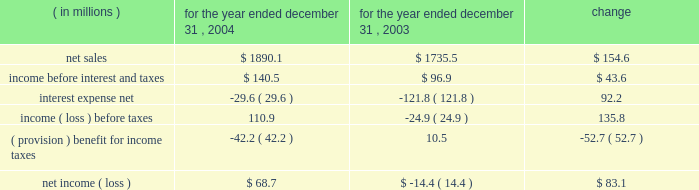Year ended december 31 , 2004 compared to year ended december 31 , 2003 the historical results of operations of pca for the years ended december 31 , 2004 and 2003 are set forth below : for the year ended december 31 , ( in millions ) 2004 2003 change .
Net sales net sales increased by $ 154.6 million , or 8.9% ( 8.9 % ) , for the year ended december 31 , 2004 from the year ended december 31 , 2003 .
Net sales increased due to improved sales volumes and prices of corrugated products and containerboard compared to 2003 .
Total corrugated products volume sold increased 6.6% ( 6.6 % ) to 29.9 billion square feet in 2004 compared to 28.1 billion square feet in 2003 .
On a comparable shipment-per-workday basis , corrugated products sales volume increased 7.0% ( 7.0 % ) in 2004 from 2003 .
Excluding pca 2019s acquisition of acorn in february 2004 , corrugated products volume was 5.3% ( 5.3 % ) higher in 2004 than 2003 and up 5.8% ( 5.8 % ) compared to 2003 on a shipment-per-workday basis .
Shipments-per-workday is calculated by dividing our total corrugated products volume during the year by the number of workdays within the year .
The larger percentage increase was due to the fact that 2004 had one less workday ( 251 days ) , those days not falling on a weekend or holiday , than 2003 ( 252 days ) .
Containerboard sales volume to external domestic and export customers increased 6.8% ( 6.8 % ) to 475000 tons for the year ended december 31 , 2004 from 445000 tons in 2003 .
Income before interest and taxes income before interest and taxes increased by $ 43.6 million , or 45.1% ( 45.1 % ) , for the year ended december 31 , 2004 compared to 2003 .
Included in income before interest and taxes for the year ended december 31 , 2004 is income of $ 27.8 million , net of expenses , attributable to a dividend paid to pca by stv , the timberlands joint venture in which pca owns a 311 20443% ( 20443 % ) ownership interest .
Included in income before interest and taxes for the year ended december 31 , 2003 is a $ 3.3 million charge for fees and expenses related to the company 2019s debt refinancing which was completed in july 2003 , and a fourth quarter charge of $ 16.0 million to settle certain benefits related matters with pactiv corporation dating back to april 12 , 1999 when pca became a stand-alone company , as described below .
During the fourth quarter of 2003 , pactiv notified pca that we owed pactiv additional amounts for hourly pension benefits and workers 2019 compensation liabilities dating back to april 12 , 1999 .
A settlement of $ 16.0 million was negotiated between pactiv and pca in december 2003 .
The full amount of the settlement was accrued in the fourth quarter of 2003 .
Excluding these special items , operating income decreased $ 3.4 million in 2004 compared to 2003 .
The $ 3.4 million decrease in income before interest and taxes was primarily attributable to increased energy and transportation costs ( $ 19.2 million ) , higher recycled and wood fiber costs ( $ 16.7 million ) , increased salary expenses related to annual increases and new hires ( $ 5.7 million ) , and increased contractual hourly labor costs ( $ 5.6 million ) , which was partially offset by increased sales volume and sales prices ( $ 44.3 million ) . .
What was the change in total corrugated products volume sold in billion square feet from 2004 compared to 2003? 
Computations: (29.9 - 28.1)
Answer: 1.8. 